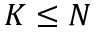Convert formula to latex. <formula><loc_0><loc_0><loc_500><loc_500>K \leq N</formula> 